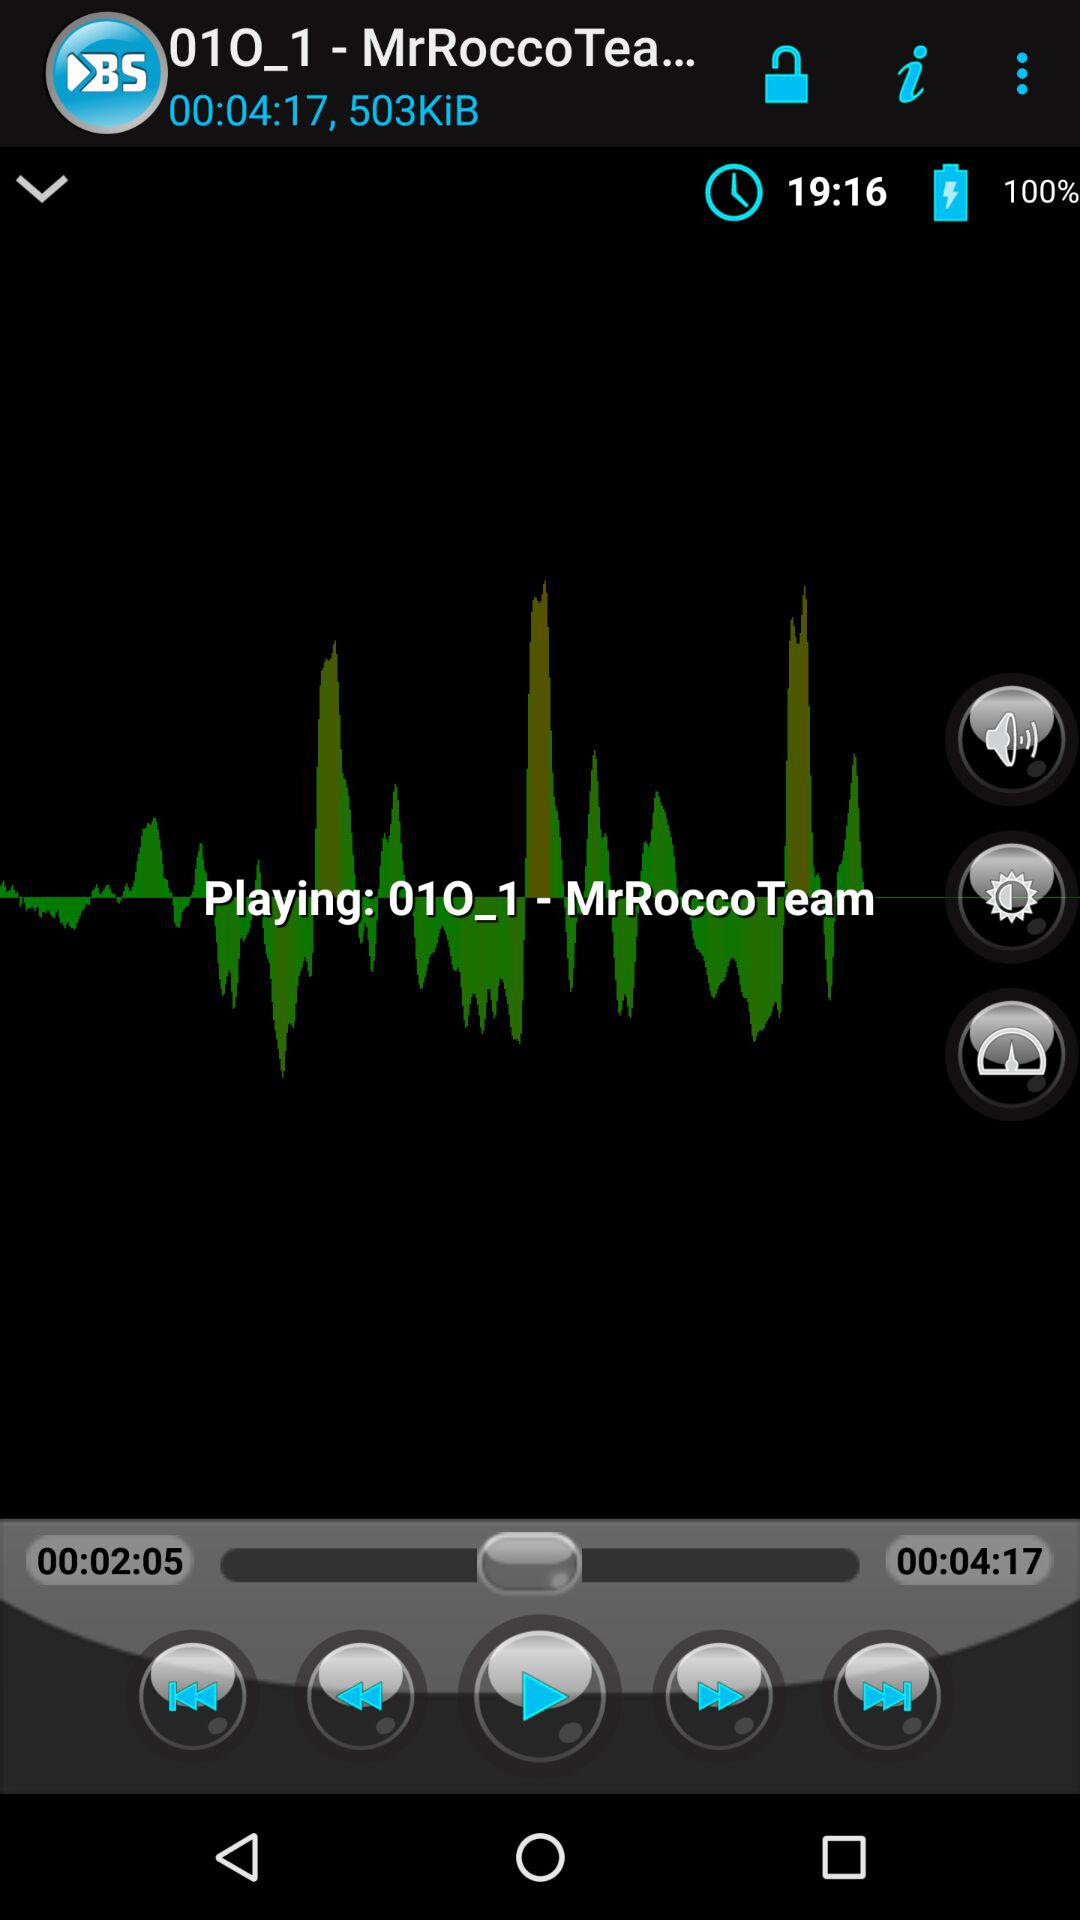What is the total length of the audio? The total length of the audio is 4 minutes and 17 seconds. 